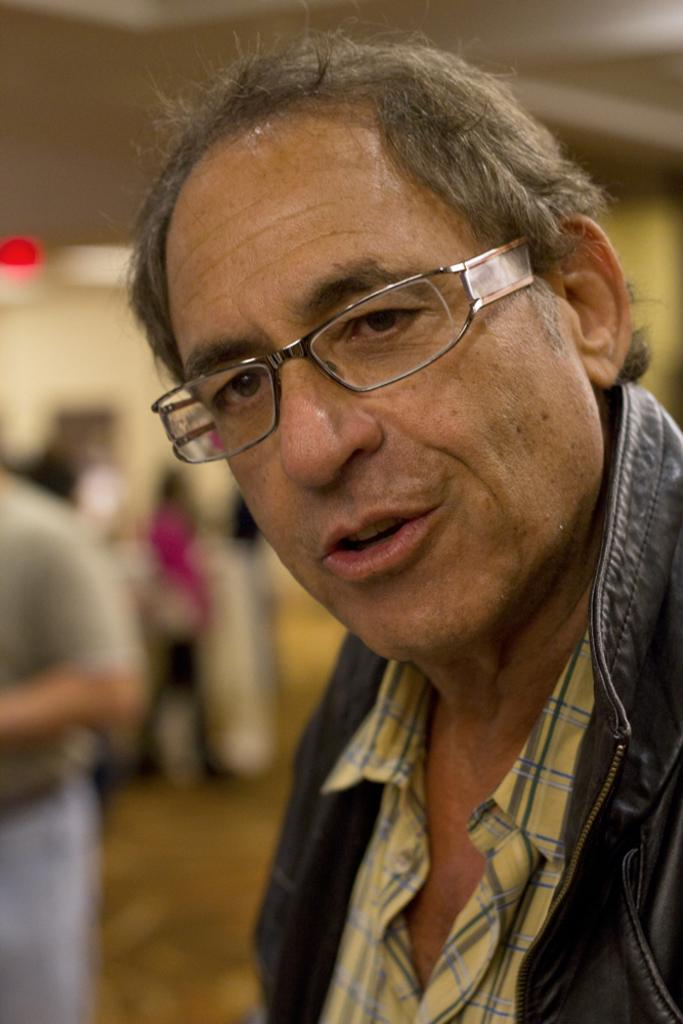What is the main subject of the image? There is a person in the image. What is the person wearing? The person is wearing a blue object. Can you describe the background of the image? The background of the image is blurred. What type of treatment is the person receiving in the image? There is no indication in the image that the person is receiving any treatment. 